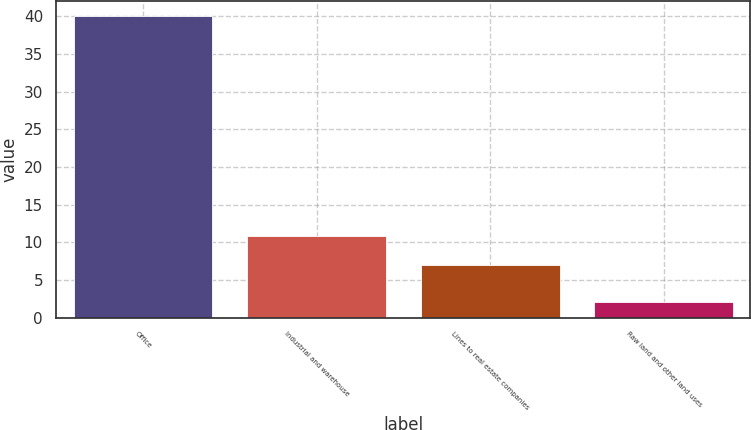Convert chart to OTSL. <chart><loc_0><loc_0><loc_500><loc_500><bar_chart><fcel>Office<fcel>Industrial and warehouse<fcel>Lines to real estate companies<fcel>Raw land and other land uses<nl><fcel>40<fcel>10.8<fcel>7<fcel>2<nl></chart> 